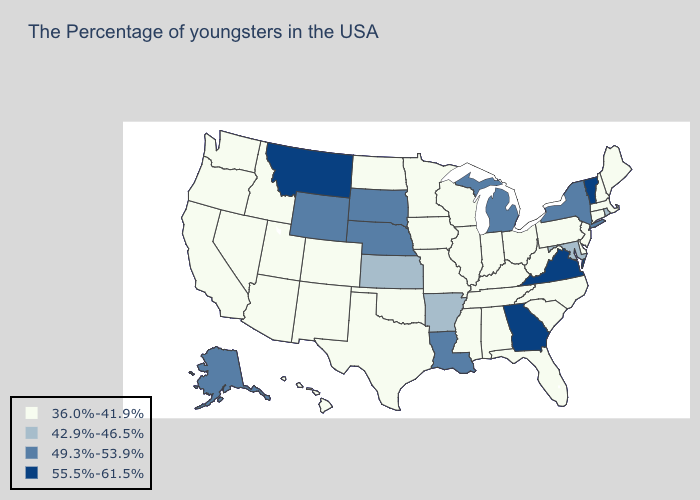Which states have the lowest value in the South?
Answer briefly. Delaware, North Carolina, South Carolina, West Virginia, Florida, Kentucky, Alabama, Tennessee, Mississippi, Oklahoma, Texas. What is the value of California?
Be succinct. 36.0%-41.9%. What is the lowest value in the USA?
Give a very brief answer. 36.0%-41.9%. What is the highest value in states that border Illinois?
Be succinct. 36.0%-41.9%. Which states have the lowest value in the Northeast?
Write a very short answer. Maine, Massachusetts, New Hampshire, Connecticut, New Jersey, Pennsylvania. Which states have the highest value in the USA?
Concise answer only. Vermont, Virginia, Georgia, Montana. How many symbols are there in the legend?
Write a very short answer. 4. What is the value of Idaho?
Keep it brief. 36.0%-41.9%. Which states have the highest value in the USA?
Concise answer only. Vermont, Virginia, Georgia, Montana. What is the value of Mississippi?
Write a very short answer. 36.0%-41.9%. What is the value of Hawaii?
Be succinct. 36.0%-41.9%. What is the lowest value in the USA?
Short answer required. 36.0%-41.9%. Does the map have missing data?
Short answer required. No. How many symbols are there in the legend?
Write a very short answer. 4. What is the highest value in states that border Tennessee?
Give a very brief answer. 55.5%-61.5%. 